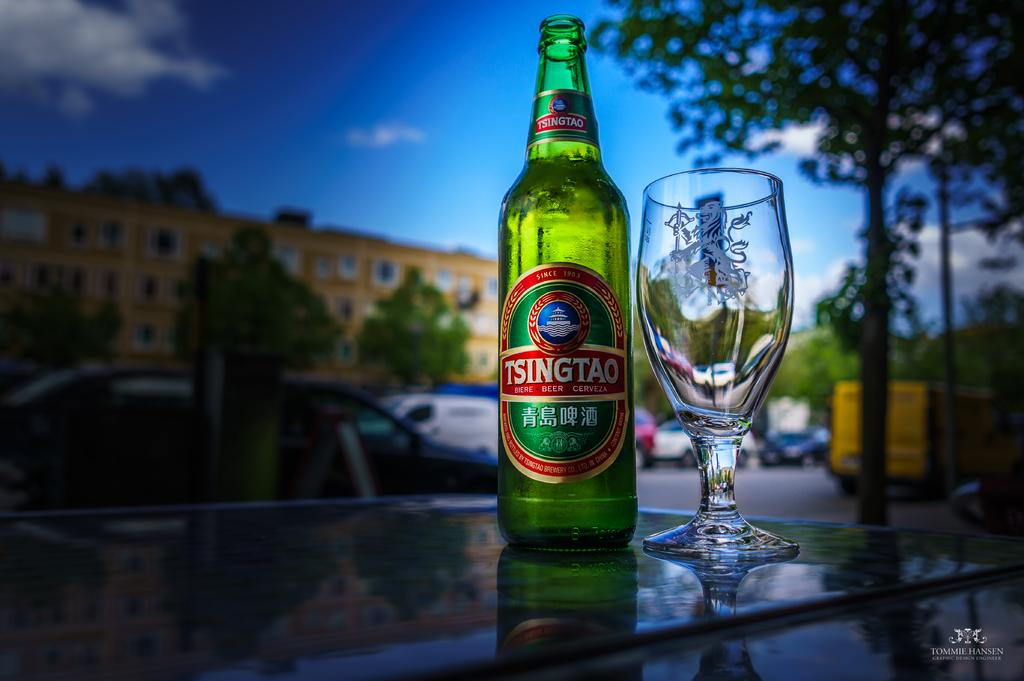What can be seen in the sky in the image? There is a sky in the image. What type of natural element is present in the image? There is a tree in the image. What type of man-made structure is present in the image? There is a building in the image. What type of vehicles are present in the image? There are cars in the image. What type of furniture is present in the image? There is a table in the image. What type of objects are on the table in the image? There is a glass and a bottle on the table in the image. What type of humor can be seen in the image? There is no humor present in the image; it is a scene with a sky, tree, building, cars, table, glass, and bottle. What type of request can be seen in the image? There is no request present in the image; it is a static scene with various elements. 